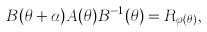<formula> <loc_0><loc_0><loc_500><loc_500>B ( \theta + \alpha ) A ( \theta ) B ^ { - 1 } ( \theta ) = R _ { \varphi ( \theta ) } ,</formula> 